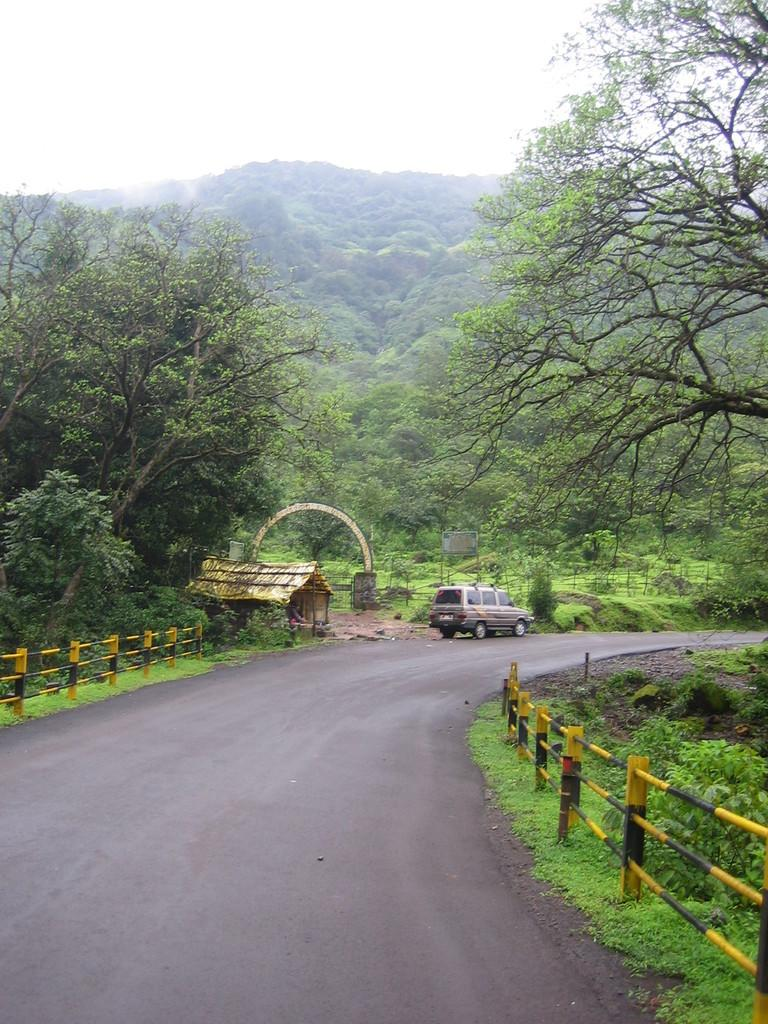What is on the road in the image? There is a vehicle on the road in the image. What type of vegetation is present on both sides of the road? There is grass on both the left and right sides of the road in the image. What can be seen in the background of the image? There are trees visible in the background of the image. What type of scissors can be seen cutting the ice on the road in the image? There are no scissors or ice present in the image; it features a vehicle on the road with grass on both sides and trees in the background. 